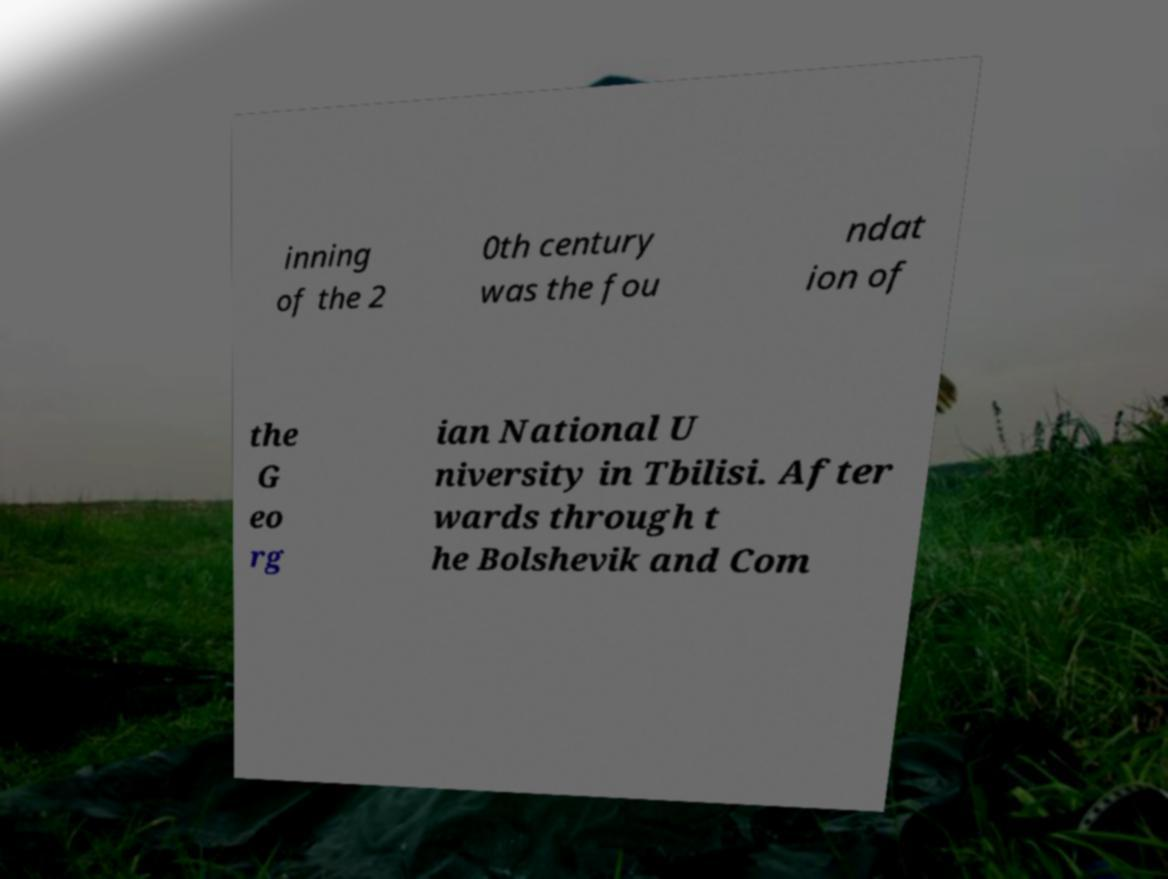Please identify and transcribe the text found in this image. inning of the 2 0th century was the fou ndat ion of the G eo rg ian National U niversity in Tbilisi. After wards through t he Bolshevik and Com 